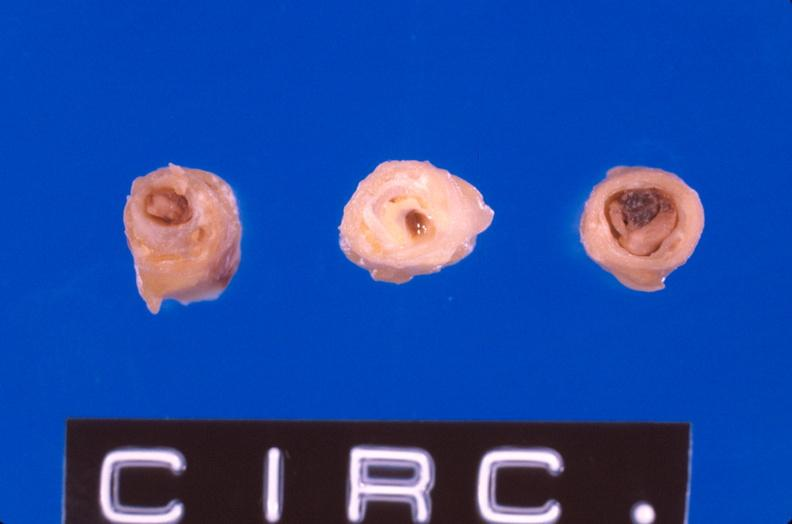what is present?
Answer the question using a single word or phrase. Vasculature 